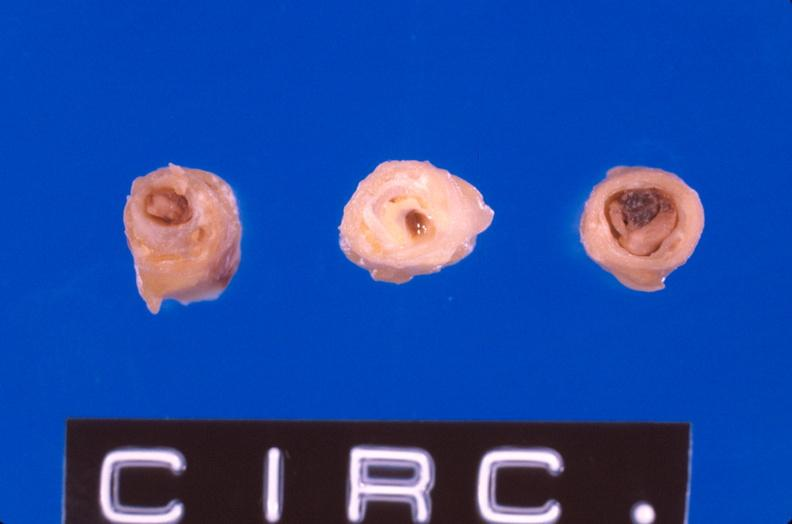what is present?
Answer the question using a single word or phrase. Vasculature 